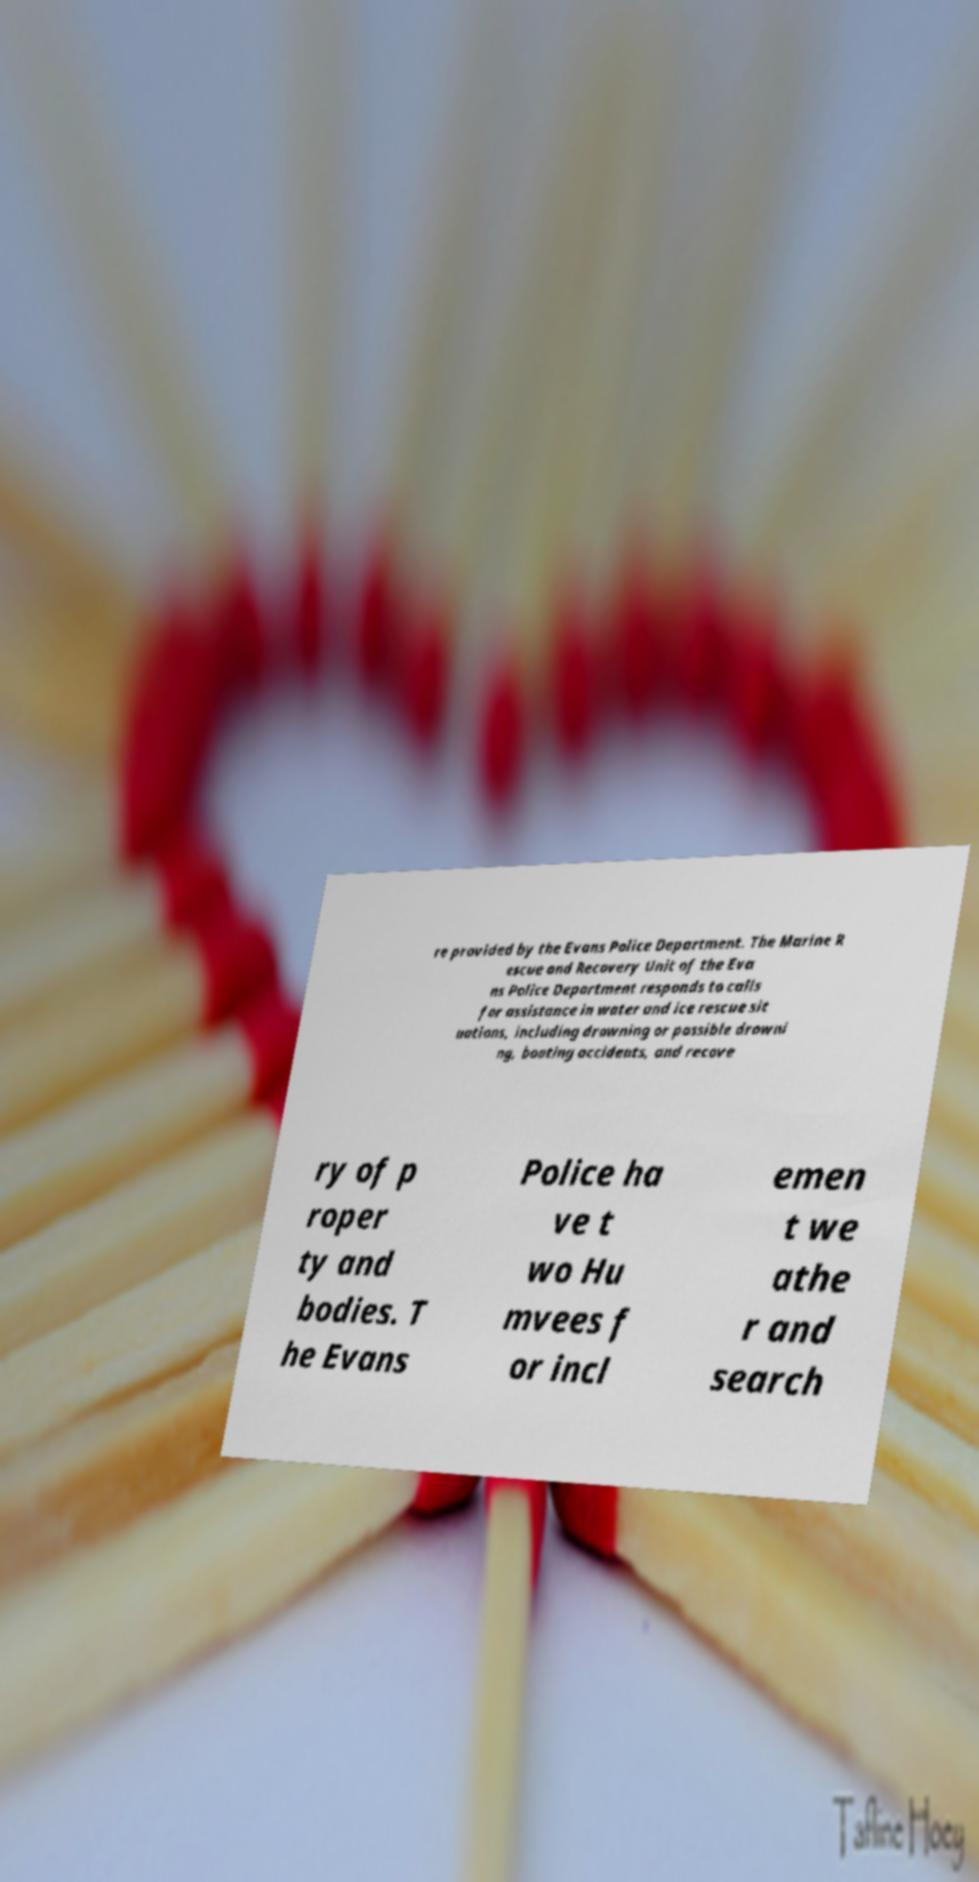Please read and relay the text visible in this image. What does it say? re provided by the Evans Police Department. The Marine R escue and Recovery Unit of the Eva ns Police Department responds to calls for assistance in water and ice rescue sit uations, including drowning or possible drowni ng, boating accidents, and recove ry of p roper ty and bodies. T he Evans Police ha ve t wo Hu mvees f or incl emen t we athe r and search 